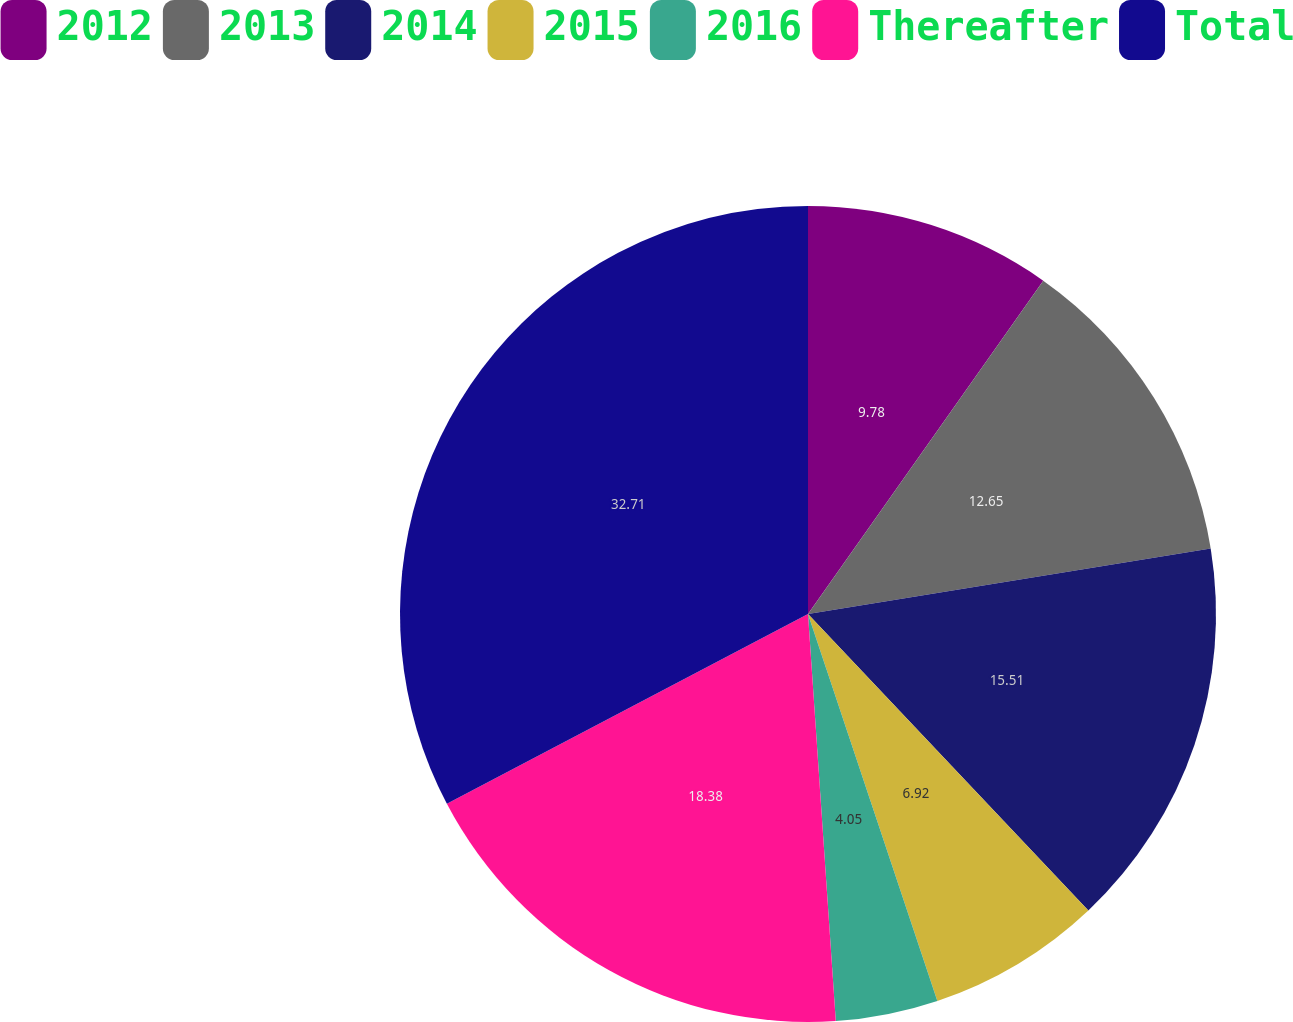Convert chart. <chart><loc_0><loc_0><loc_500><loc_500><pie_chart><fcel>2012<fcel>2013<fcel>2014<fcel>2015<fcel>2016<fcel>Thereafter<fcel>Total<nl><fcel>9.78%<fcel>12.65%<fcel>15.51%<fcel>6.92%<fcel>4.05%<fcel>18.38%<fcel>32.7%<nl></chart> 